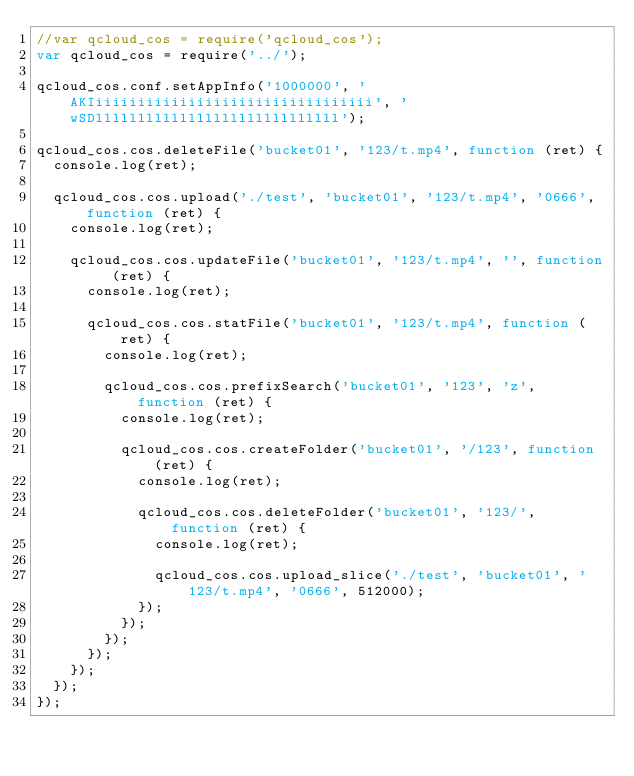Convert code to text. <code><loc_0><loc_0><loc_500><loc_500><_JavaScript_>//var qcloud_cos = require('qcloud_cos');
var qcloud_cos = require('../');

qcloud_cos.conf.setAppInfo('1000000', 'AKIiiiiiiiiiiiiiiiiiiiiiiiiiiiiiiiii', 'wSDlllllllllllllllllllllllllllll');

qcloud_cos.cos.deleteFile('bucket01', '123/t.mp4', function (ret) {
  console.log(ret);

  qcloud_cos.cos.upload('./test', 'bucket01', '123/t.mp4', '0666', function (ret) {
    console.log(ret);

    qcloud_cos.cos.updateFile('bucket01', '123/t.mp4', '', function (ret) {
      console.log(ret);

      qcloud_cos.cos.statFile('bucket01', '123/t.mp4', function (ret) {
        console.log(ret);

        qcloud_cos.cos.prefixSearch('bucket01', '123', 'z', function (ret) {
          console.log(ret);

          qcloud_cos.cos.createFolder('bucket01', '/123', function (ret) {
            console.log(ret);

            qcloud_cos.cos.deleteFolder('bucket01', '123/', function (ret) {
              console.log(ret);

              qcloud_cos.cos.upload_slice('./test', 'bucket01', '123/t.mp4', '0666', 512000);
            });
          });
        });
      });
    });
  });
});
</code> 